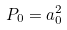<formula> <loc_0><loc_0><loc_500><loc_500>P _ { 0 } = a _ { 0 } ^ { 2 }</formula> 